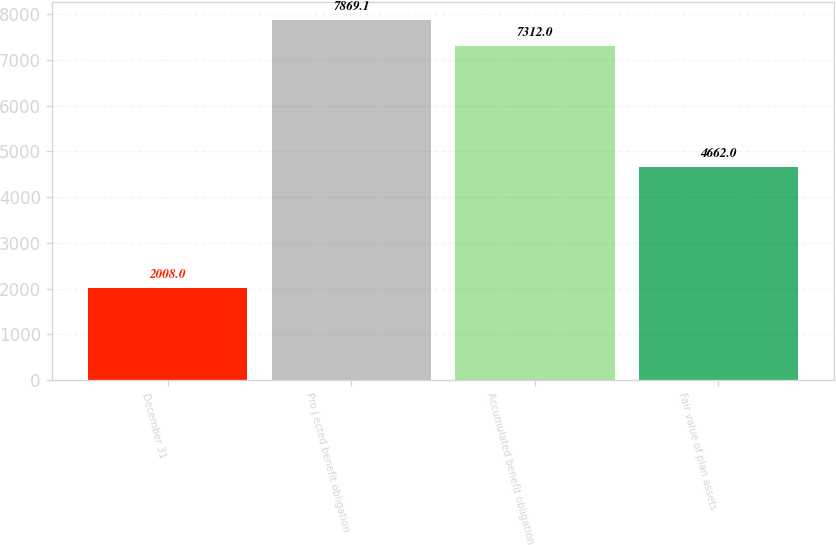Convert chart. <chart><loc_0><loc_0><loc_500><loc_500><bar_chart><fcel>December 31<fcel>Pro j ected benefit obligation<fcel>Accumulated benefit obligation<fcel>Fair value of plan assets<nl><fcel>2008<fcel>7869.1<fcel>7312<fcel>4662<nl></chart> 